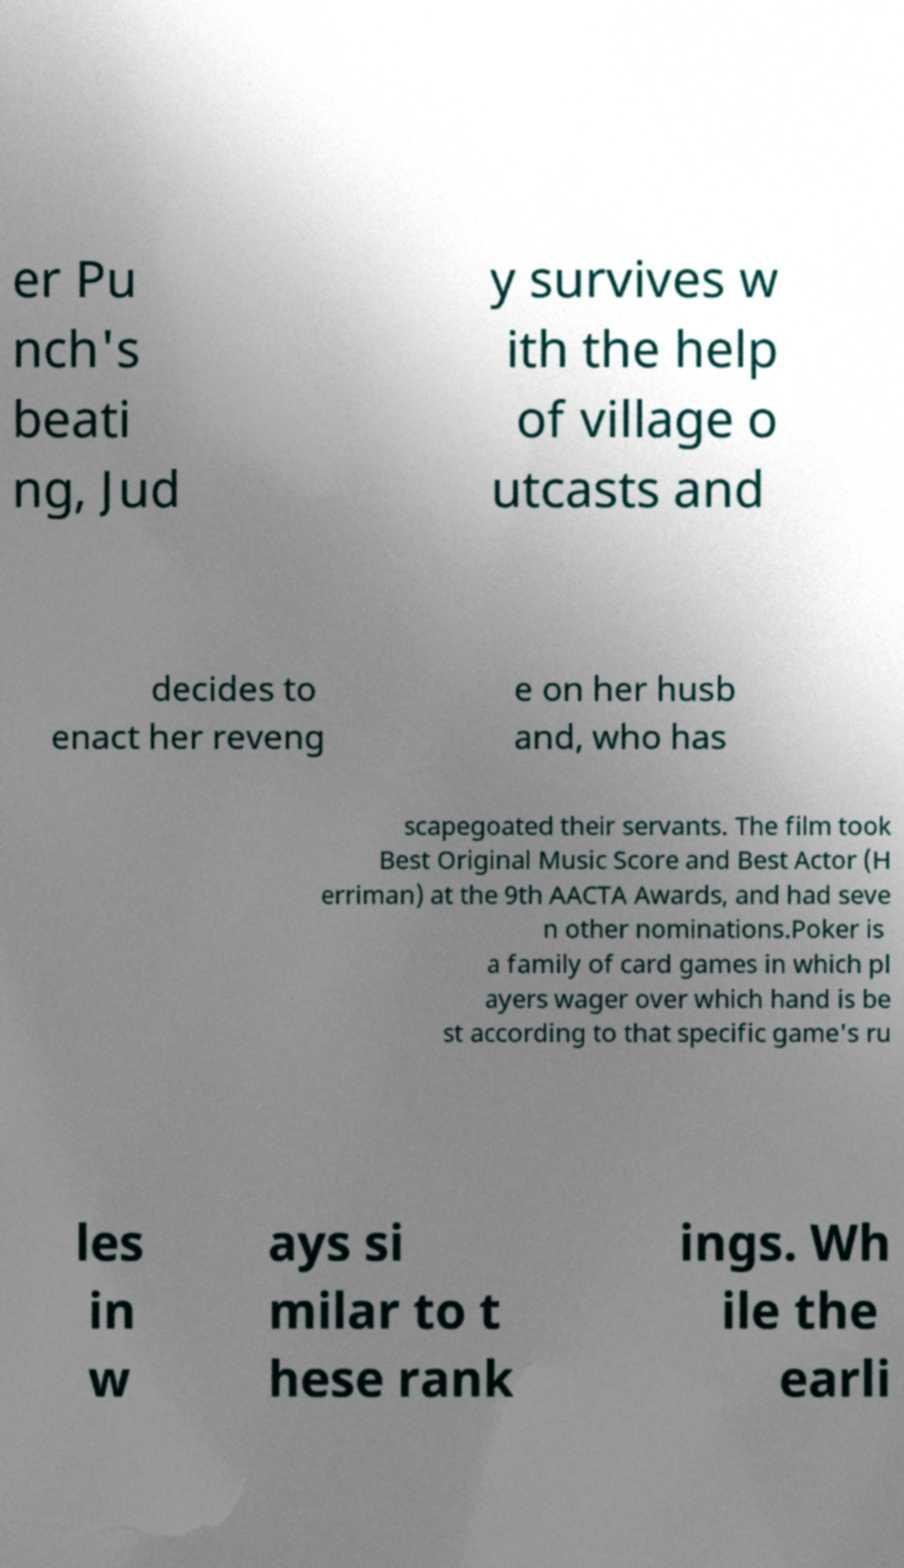Please read and relay the text visible in this image. What does it say? er Pu nch's beati ng, Jud y survives w ith the help of village o utcasts and decides to enact her reveng e on her husb and, who has scapegoated their servants. The film took Best Original Music Score and Best Actor (H erriman) at the 9th AACTA Awards, and had seve n other nominations.Poker is a family of card games in which pl ayers wager over which hand is be st according to that specific game's ru les in w ays si milar to t hese rank ings. Wh ile the earli 